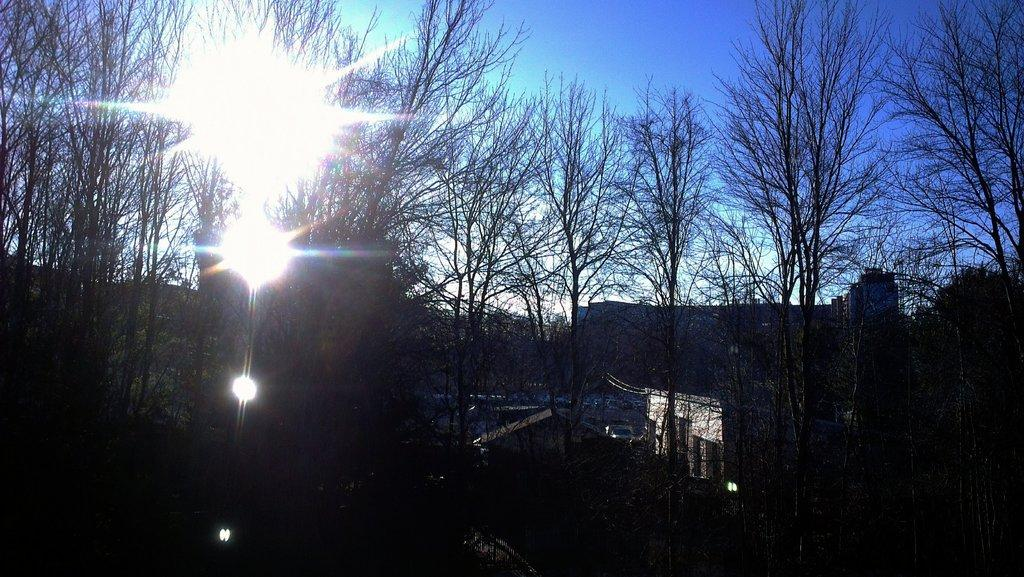What type of natural elements can be seen in the image? There are many trees in the image. What man-made structures are present in the image? There are vehicles, buildings, and lights in the image. What can be seen in the background of the image? The sky is visible in the background of the image. What type of beast can be seen roaming around in the image? There is no beast present in the image; it features trees, vehicles, buildings, lights, and a visible sky. Is there a prison visible in the image? There is no prison present in the image. 